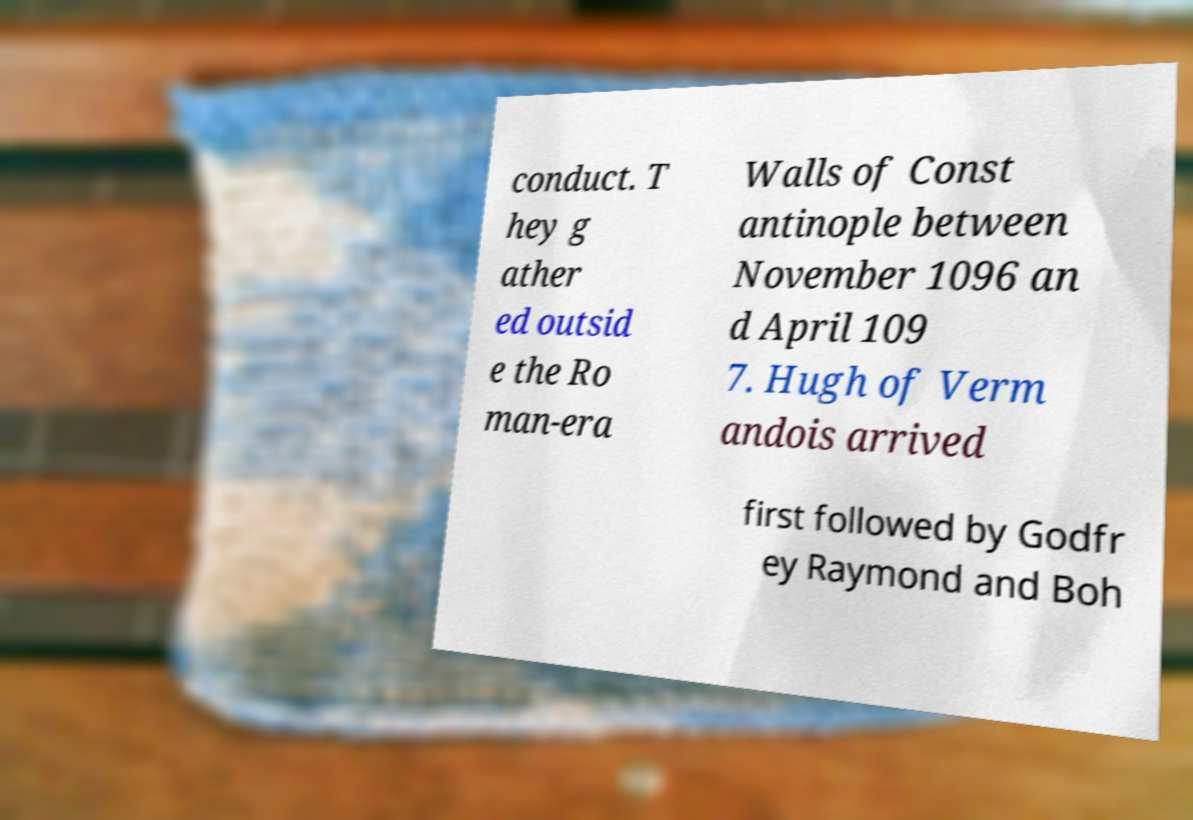Can you accurately transcribe the text from the provided image for me? conduct. T hey g ather ed outsid e the Ro man-era Walls of Const antinople between November 1096 an d April 109 7. Hugh of Verm andois arrived first followed by Godfr ey Raymond and Boh 